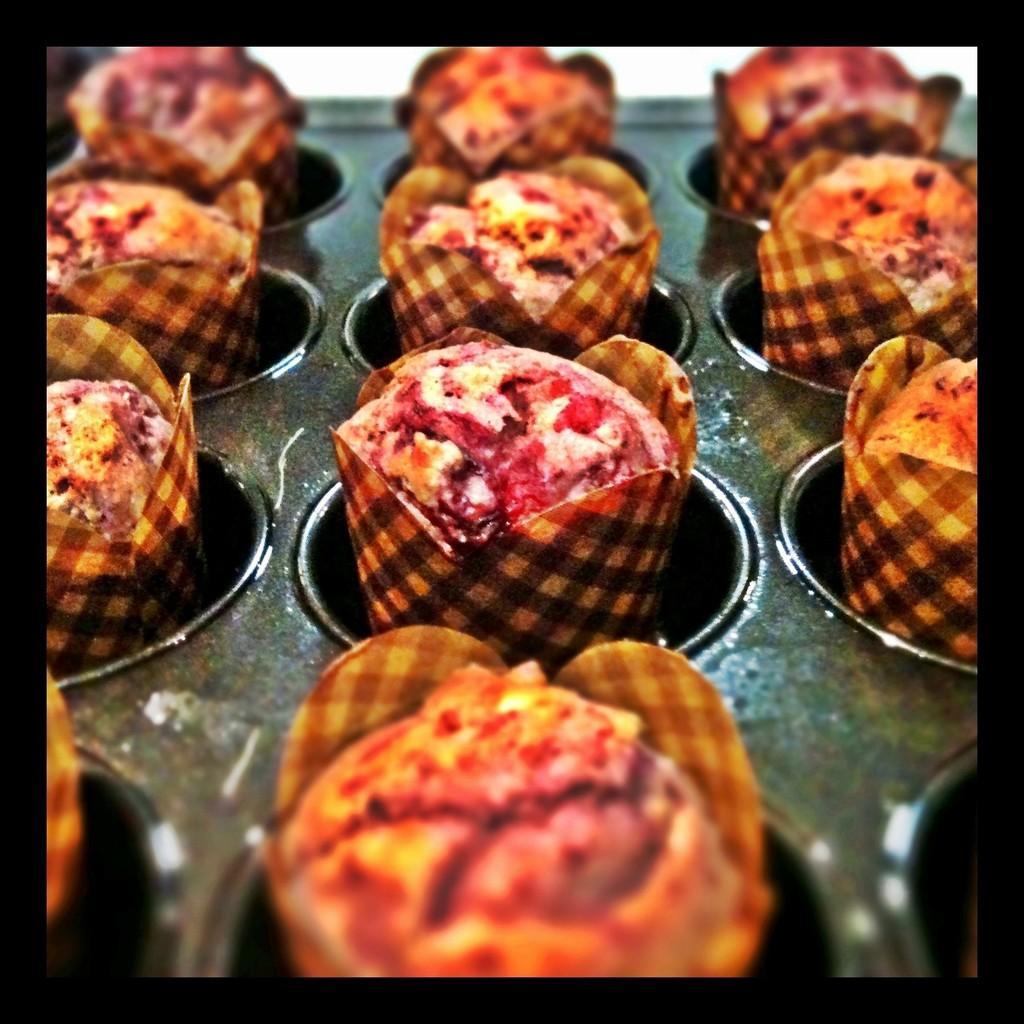Can you describe this image briefly? In this picture I can observe some food. These are looking like cupcakes. These are in brown and red colors. 